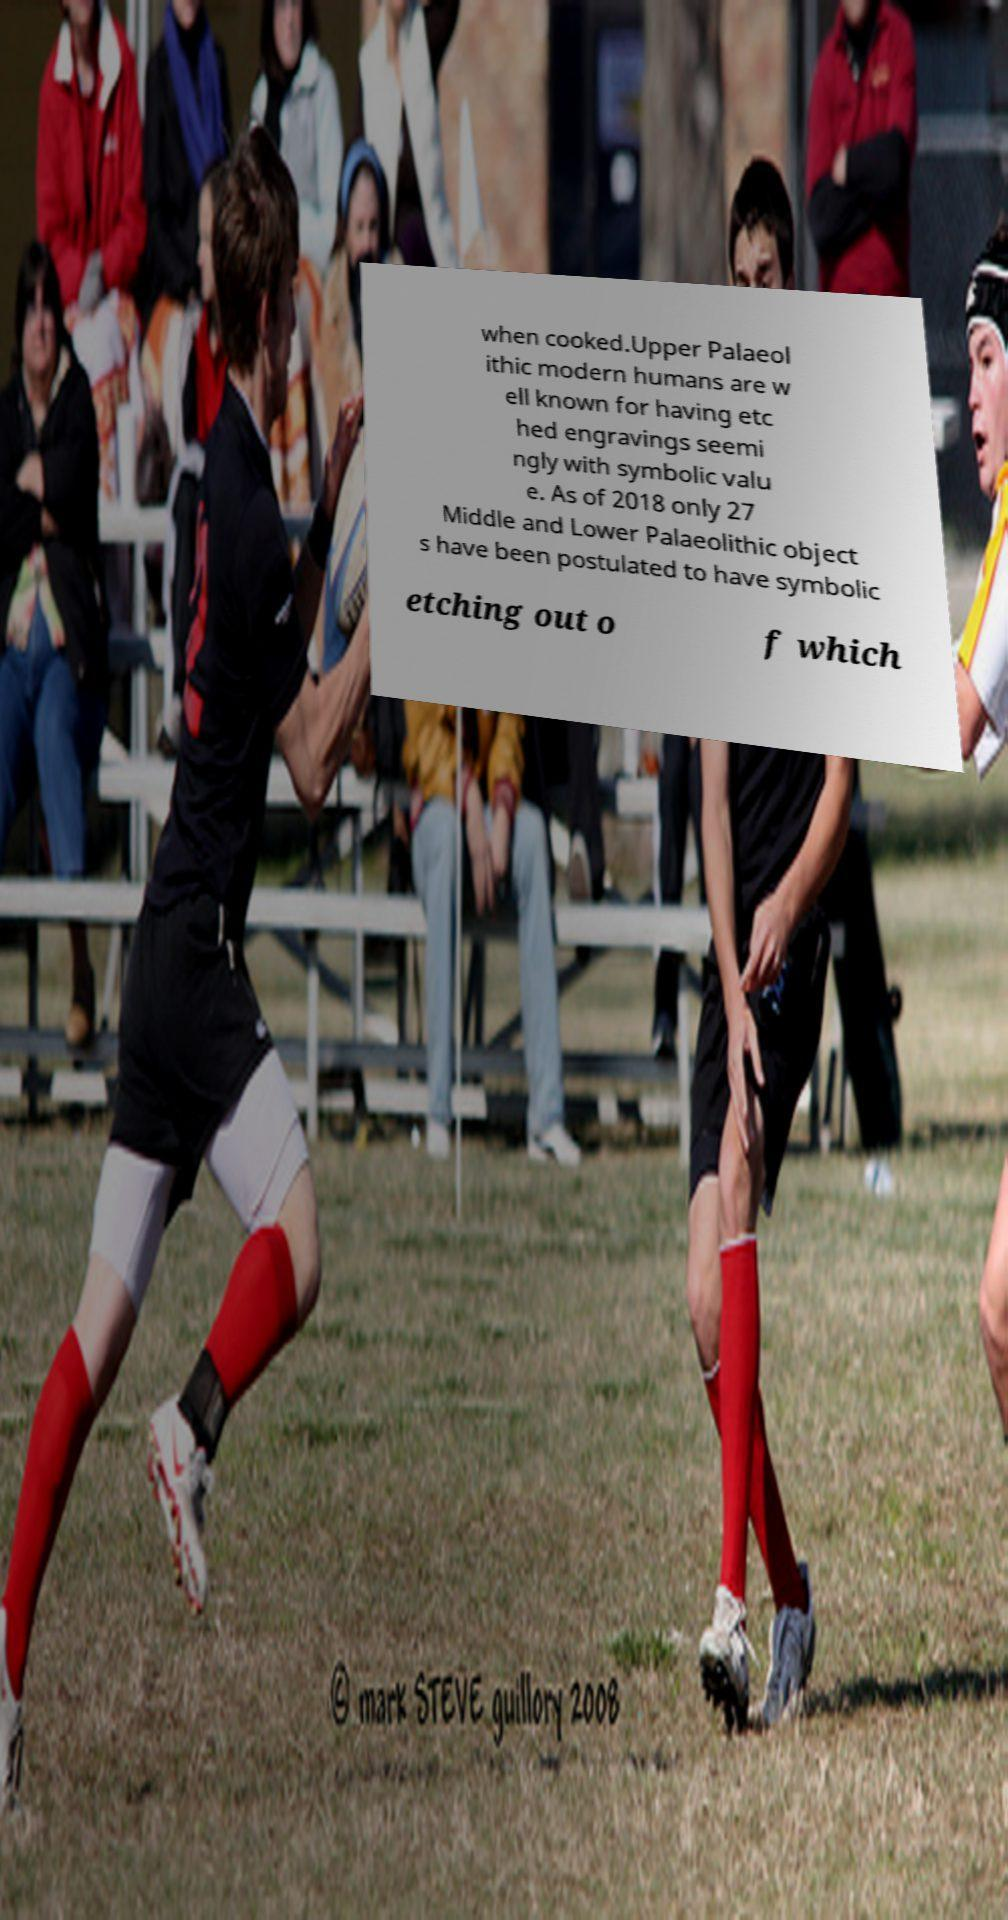I need the written content from this picture converted into text. Can you do that? when cooked.Upper Palaeol ithic modern humans are w ell known for having etc hed engravings seemi ngly with symbolic valu e. As of 2018 only 27 Middle and Lower Palaeolithic object s have been postulated to have symbolic etching out o f which 